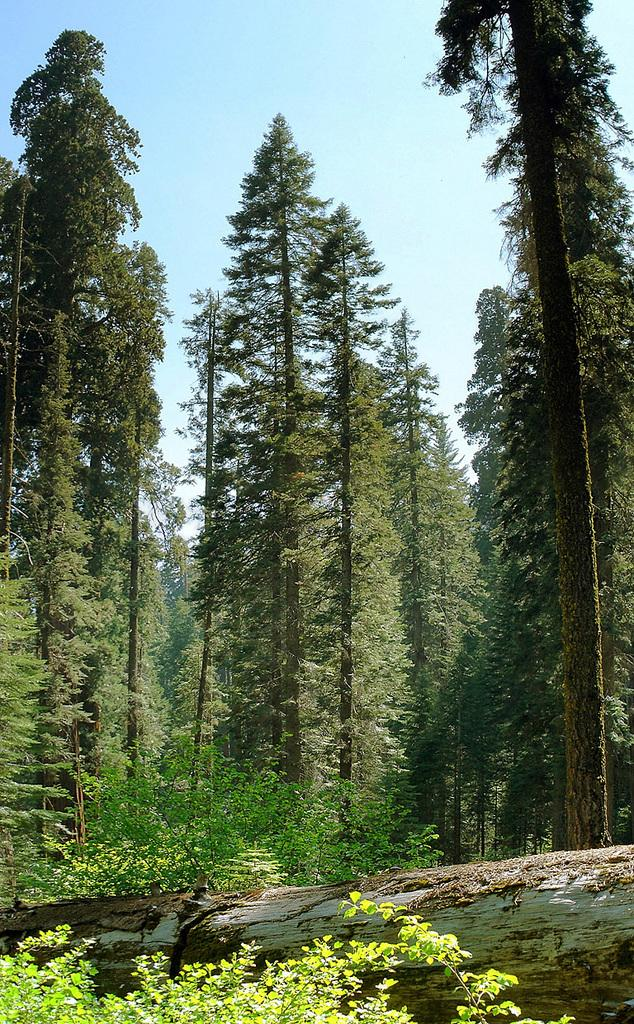What type of vegetation can be seen in the image? There are trees and plants in the image. Can you describe the fallen branch in the image? Yes, there is a fallen branch on the ground in the image. What part of the natural environment is visible in the image? The sky is visible in the image. What type of servant is shown working in the image? There is no servant present in the image; it features trees, plants, a fallen branch, and the sky. What punishment is being administered to the trees in the image? There is no punishment being administered to the trees in the image; they are simply standing or growing in their natural state. 